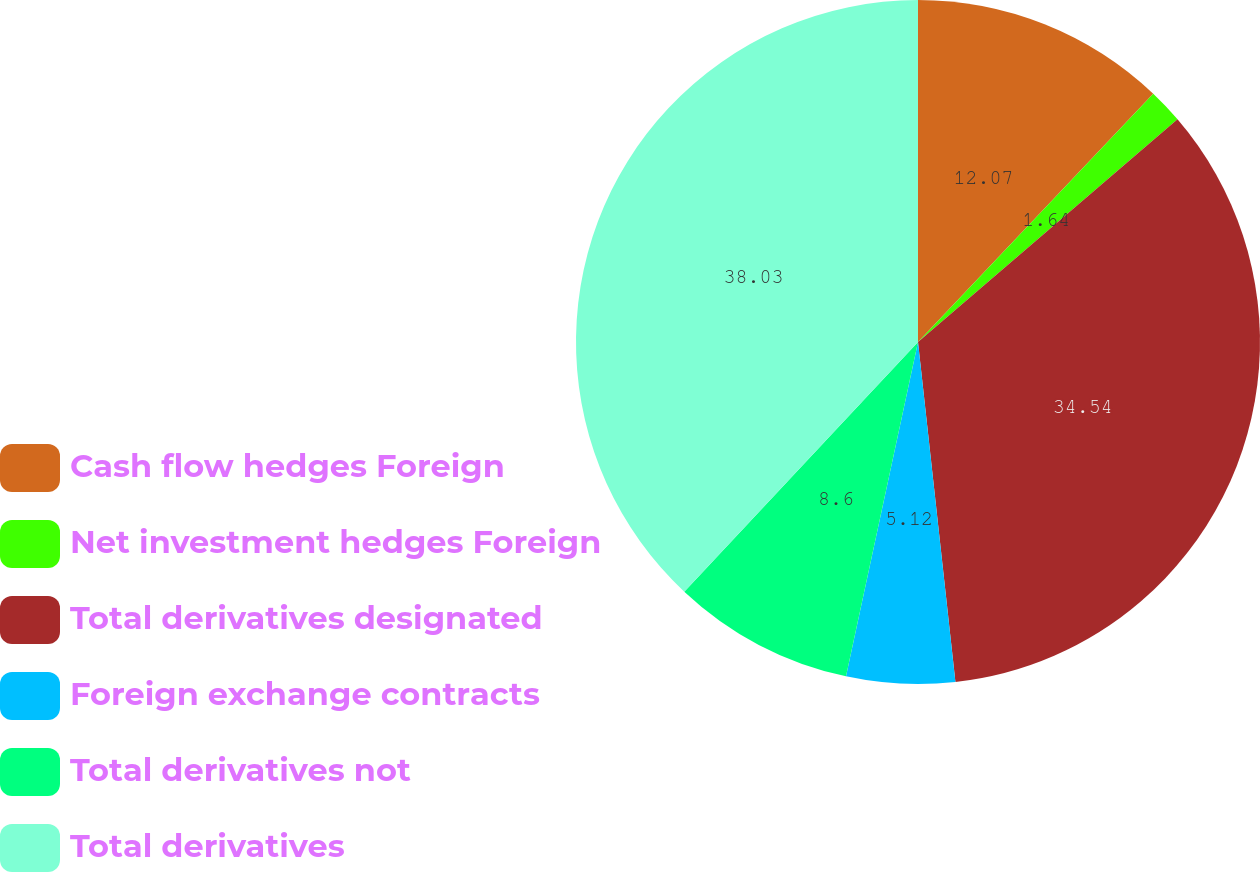<chart> <loc_0><loc_0><loc_500><loc_500><pie_chart><fcel>Cash flow hedges Foreign<fcel>Net investment hedges Foreign<fcel>Total derivatives designated<fcel>Foreign exchange contracts<fcel>Total derivatives not<fcel>Total derivatives<nl><fcel>12.07%<fcel>1.64%<fcel>34.54%<fcel>5.12%<fcel>8.6%<fcel>38.02%<nl></chart> 